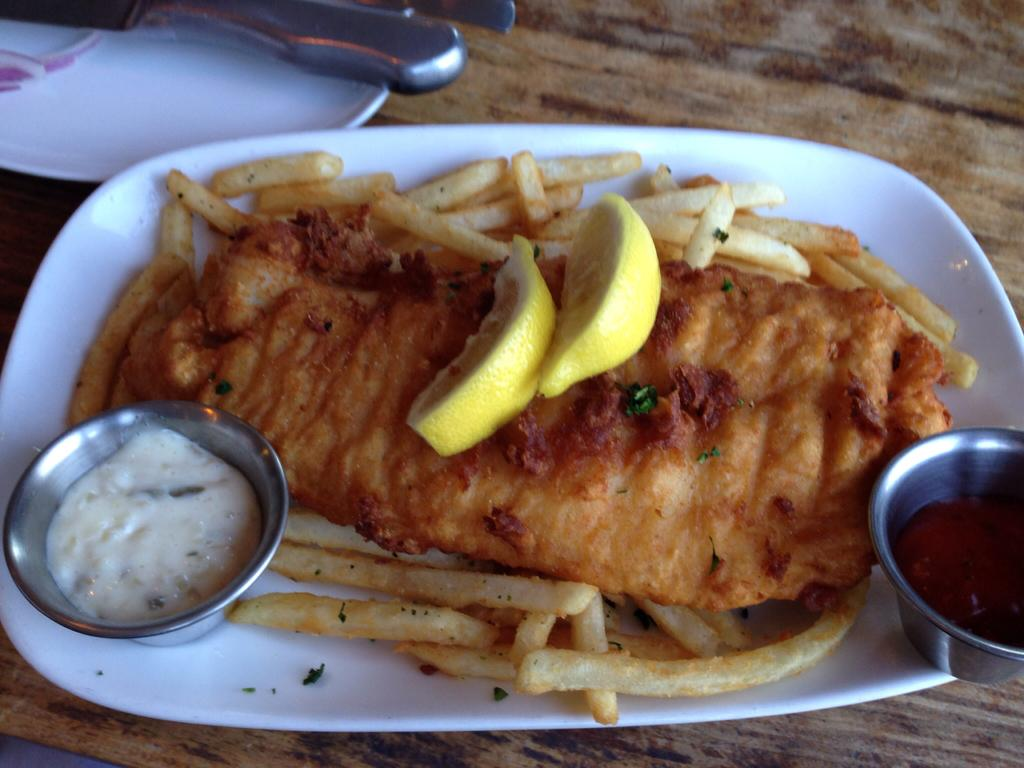What is on the plate in the image? There is a cooked food item on a plate in the image. How many sauces are on the plate? There are two different sauces on the plate. What is placed on top of the food item? There are two lemon slices on the food item. What type of surface is the plate resting on? The plate is on a wooden table. What type of rod is used to support the discovery in the image? There is no rod or discovery present in the image; it features a plate with a cooked food item, sauces, and lemon slices on a wooden table. 